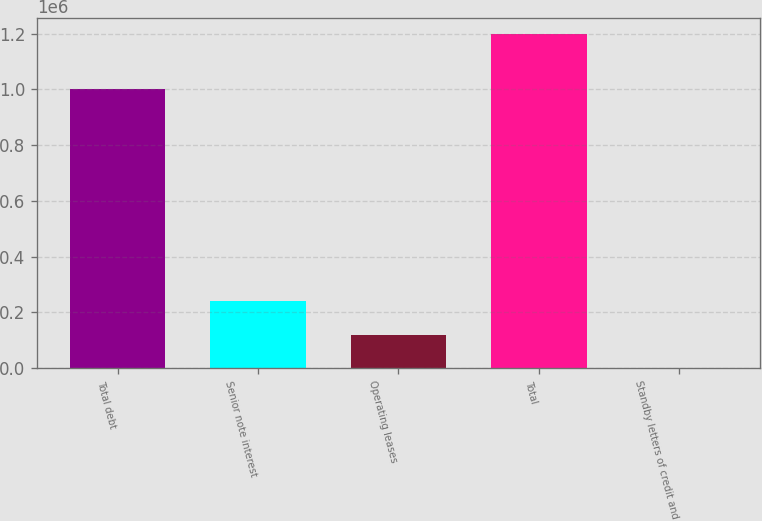Convert chart. <chart><loc_0><loc_0><loc_500><loc_500><bar_chart><fcel>Total debt<fcel>Senior note interest<fcel>Operating leases<fcel>Total<fcel>Standby letters of credit and<nl><fcel>1e+06<fcel>239751<fcel>120017<fcel>1.19762e+06<fcel>283<nl></chart> 